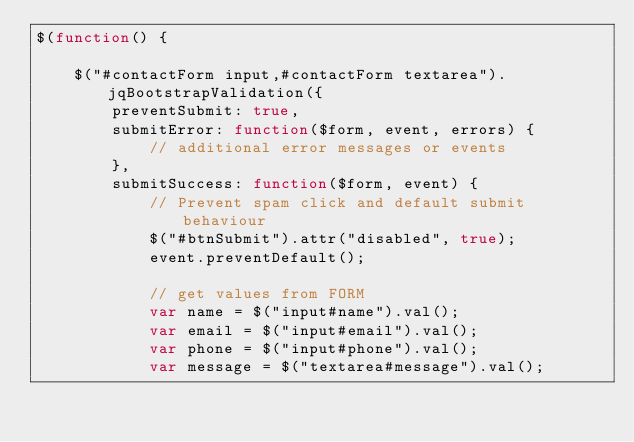<code> <loc_0><loc_0><loc_500><loc_500><_JavaScript_>$(function() {

    $("#contactForm input,#contactForm textarea").jqBootstrapValidation({
        preventSubmit: true,
        submitError: function($form, event, errors) {
            // additional error messages or events
        },
        submitSuccess: function($form, event) {
            // Prevent spam click and default submit behaviour
            $("#btnSubmit").attr("disabled", true);
            event.preventDefault();
            
            // get values from FORM
            var name = $("input#name").val();
            var email = $("input#email").val();
            var phone = $("input#phone").val();
            var message = $("textarea#message").val();</code> 